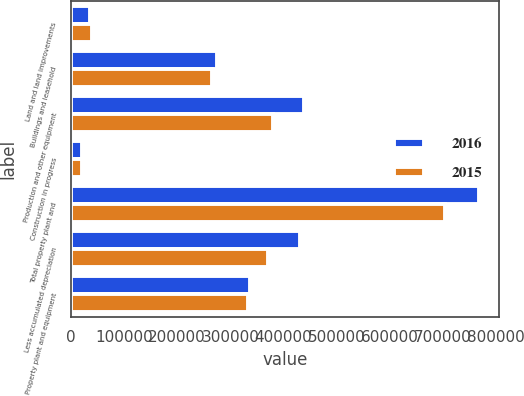Convert chart to OTSL. <chart><loc_0><loc_0><loc_500><loc_500><stacked_bar_chart><ecel><fcel>Land and land improvements<fcel>Buildings and leasehold<fcel>Production and other equipment<fcel>Construction in progress<fcel>Total property plant and<fcel>Less accumulated depreciation<fcel>Property plant and equipment<nl><fcel>2016<fcel>35720<fcel>274021<fcel>438604<fcel>20204<fcel>768549<fcel>431431<fcel>337118<nl><fcel>2015<fcel>38735<fcel>265300<fcel>380016<fcel>20477<fcel>704528<fcel>371173<fcel>333355<nl></chart> 